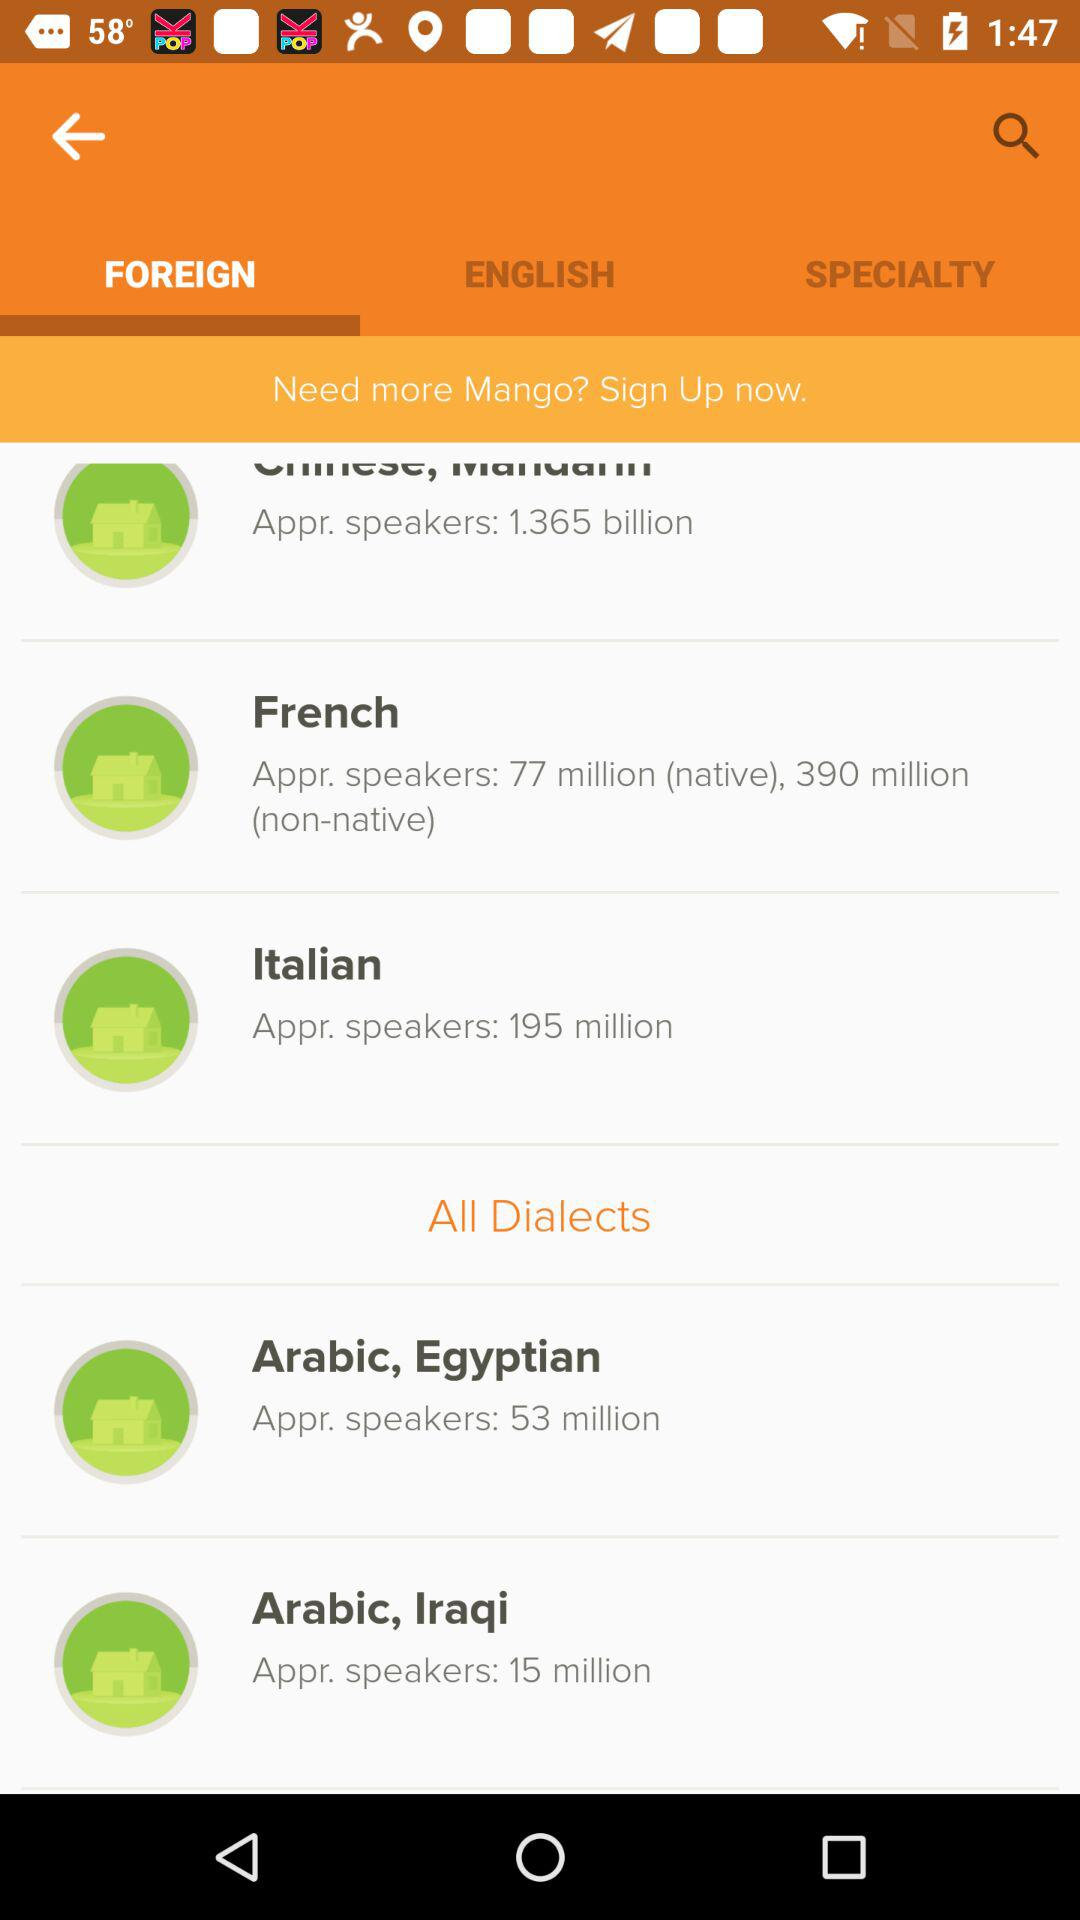How many Appr. speakers are of Italian? There are 195 million "Appr. speakers" of Italian. 